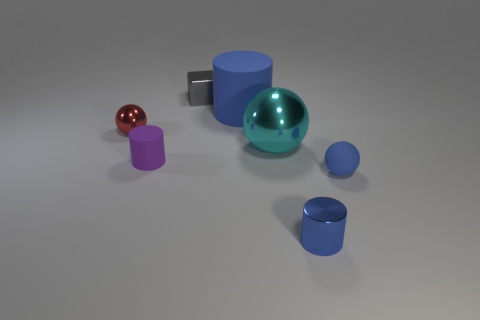Add 3 gray matte objects. How many objects exist? 10 Subtract all cubes. How many objects are left? 6 Subtract all brown cylinders. How many red balls are left? 1 Subtract all purple cylinders. Subtract all blue cylinders. How many objects are left? 4 Add 3 spheres. How many spheres are left? 6 Add 3 big yellow rubber objects. How many big yellow rubber objects exist? 3 Subtract all blue cylinders. How many cylinders are left? 1 Subtract all metal cylinders. How many cylinders are left? 2 Subtract 0 yellow balls. How many objects are left? 7 Subtract 1 cylinders. How many cylinders are left? 2 